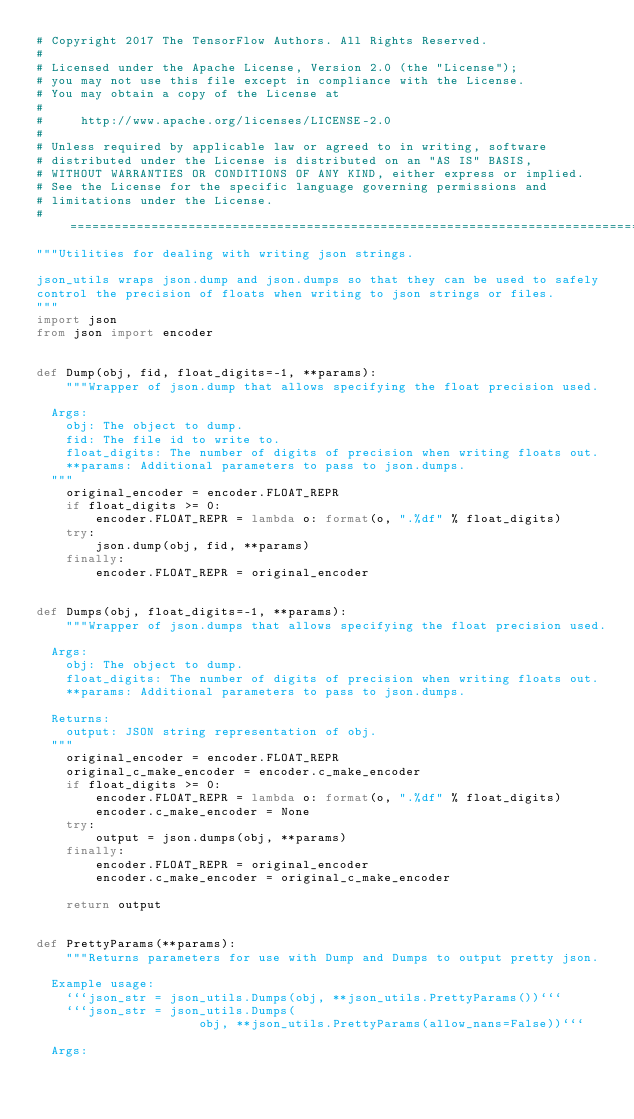Convert code to text. <code><loc_0><loc_0><loc_500><loc_500><_Python_># Copyright 2017 The TensorFlow Authors. All Rights Reserved.
#
# Licensed under the Apache License, Version 2.0 (the "License");
# you may not use this file except in compliance with the License.
# You may obtain a copy of the License at
#
#     http://www.apache.org/licenses/LICENSE-2.0
#
# Unless required by applicable law or agreed to in writing, software
# distributed under the License is distributed on an "AS IS" BASIS,
# WITHOUT WARRANTIES OR CONDITIONS OF ANY KIND, either express or implied.
# See the License for the specific language governing permissions and
# limitations under the License.
# ==============================================================================
"""Utilities for dealing with writing json strings.

json_utils wraps json.dump and json.dumps so that they can be used to safely
control the precision of floats when writing to json strings or files.
"""
import json
from json import encoder


def Dump(obj, fid, float_digits=-1, **params):
    """Wrapper of json.dump that allows specifying the float precision used.

  Args:
    obj: The object to dump.
    fid: The file id to write to.
    float_digits: The number of digits of precision when writing floats out.
    **params: Additional parameters to pass to json.dumps.
  """
    original_encoder = encoder.FLOAT_REPR
    if float_digits >= 0:
        encoder.FLOAT_REPR = lambda o: format(o, ".%df" % float_digits)
    try:
        json.dump(obj, fid, **params)
    finally:
        encoder.FLOAT_REPR = original_encoder


def Dumps(obj, float_digits=-1, **params):
    """Wrapper of json.dumps that allows specifying the float precision used.

  Args:
    obj: The object to dump.
    float_digits: The number of digits of precision when writing floats out.
    **params: Additional parameters to pass to json.dumps.

  Returns:
    output: JSON string representation of obj.
  """
    original_encoder = encoder.FLOAT_REPR
    original_c_make_encoder = encoder.c_make_encoder
    if float_digits >= 0:
        encoder.FLOAT_REPR = lambda o: format(o, ".%df" % float_digits)
        encoder.c_make_encoder = None
    try:
        output = json.dumps(obj, **params)
    finally:
        encoder.FLOAT_REPR = original_encoder
        encoder.c_make_encoder = original_c_make_encoder

    return output


def PrettyParams(**params):
    """Returns parameters for use with Dump and Dumps to output pretty json.

  Example usage:
    ```json_str = json_utils.Dumps(obj, **json_utils.PrettyParams())```
    ```json_str = json_utils.Dumps(
                      obj, **json_utils.PrettyParams(allow_nans=False))```

  Args:</code> 